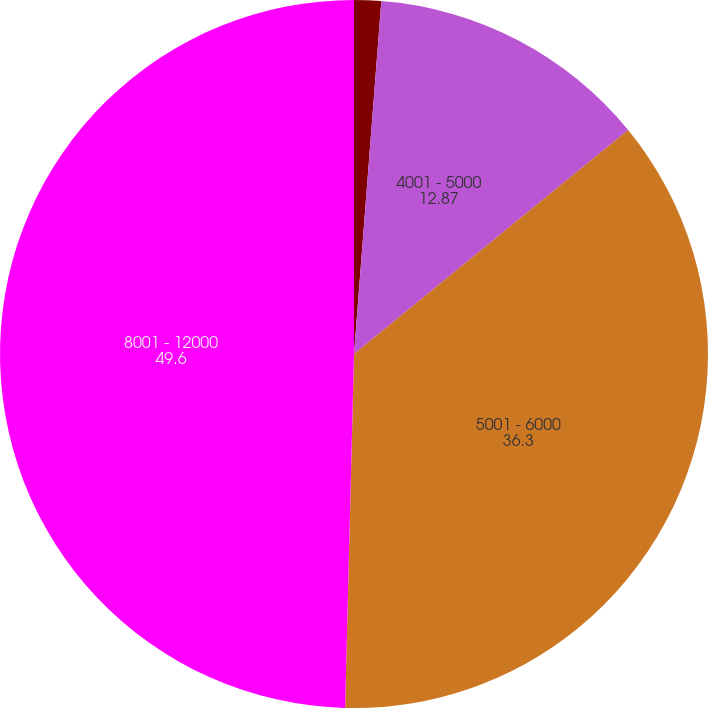<chart> <loc_0><loc_0><loc_500><loc_500><pie_chart><fcel>2000 - 4000<fcel>4001 - 5000<fcel>5001 - 6000<fcel>8001 - 12000<nl><fcel>1.23%<fcel>12.87%<fcel>36.3%<fcel>49.6%<nl></chart> 